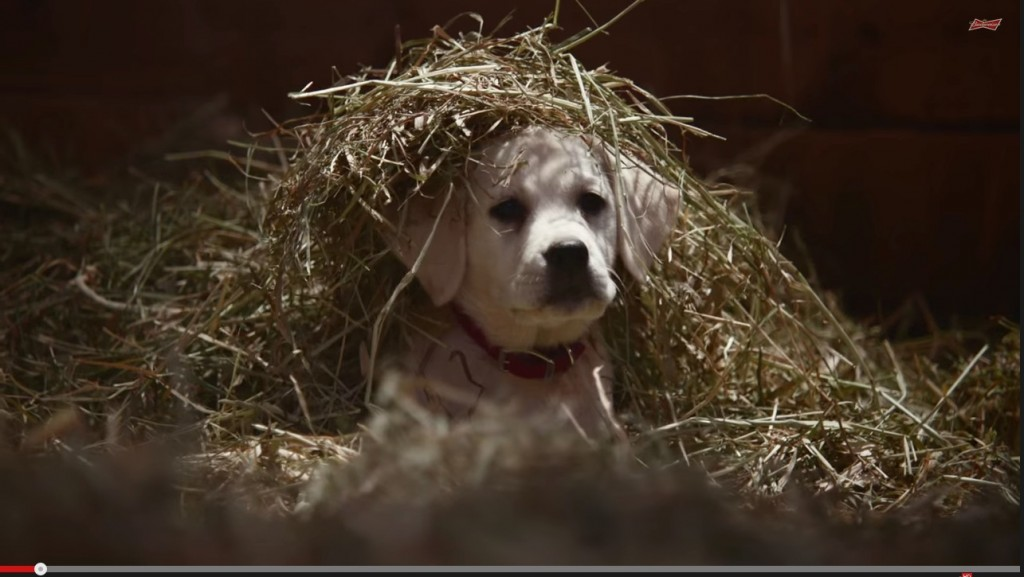What kind of adventures could this puppy have had in the barn? This adventurous puppy might have spent the day roaming through the barn, sniffing out interesting scents, and exploring hidden nooks and crannies. It could have had playful encounters with other animals, like chasing after a mischievous cat or playing hide-and-seek with the chickens. Perhaps it discovered some tasty snacks hidden in the hay or found a cozy spot to nap after all the excitement. How do you think the barn animals interact with the puppy? The barn animals likely share a friendly camaraderie with the puppy. The chickens might be curious and cautiously approach it, while the cats could either chase or be chased, depending on their mood. Larger animals like horses or cows might be more indifferent but still tolerate the puppy's playful antics. Overall, it's plausible that they coexist harmoniously, with the puppy bringing an element of lively energy to the barn. Let's imagine the puppy meets a mystical creature in the barn. What would that encounter be like? In the dim, cozy light of the barn, our curious puppy stumbled upon a hidden door behind a stack of hay bales. Intrigued, it nudged the door open and trotted inside, finding itself in a magical room filled with sparkling lights and shimmering dust. There, in the center, stood a small, ethereal creature with wings that glowed like fireflies.

"Hello, young one," the mystical creature said in a voice as soft as the wind. "I am the guardian of the barn's secrets."

The puppy, with its head tilted and ears perked, wagged its tail in response.

"You have a kind heart and a brave spirit," continued the guardian. "Tonight, I shall grant you the power to understand and communicate with all the animals of the barn."

The puppy's eyes widened in wonder as it felt a warm, tingling sensation spread through its body. It barked softly, and to its amazement, it heard a chicken cluck back in a clear response, asking, "Are you the new guardian?"

Filled with newfound purpose and excitement, the puppy spent the rest of the evening forging new bonds and understanding the stories, hopes, and dreams of its barnyard friends, all thanks to its magical encounter. 